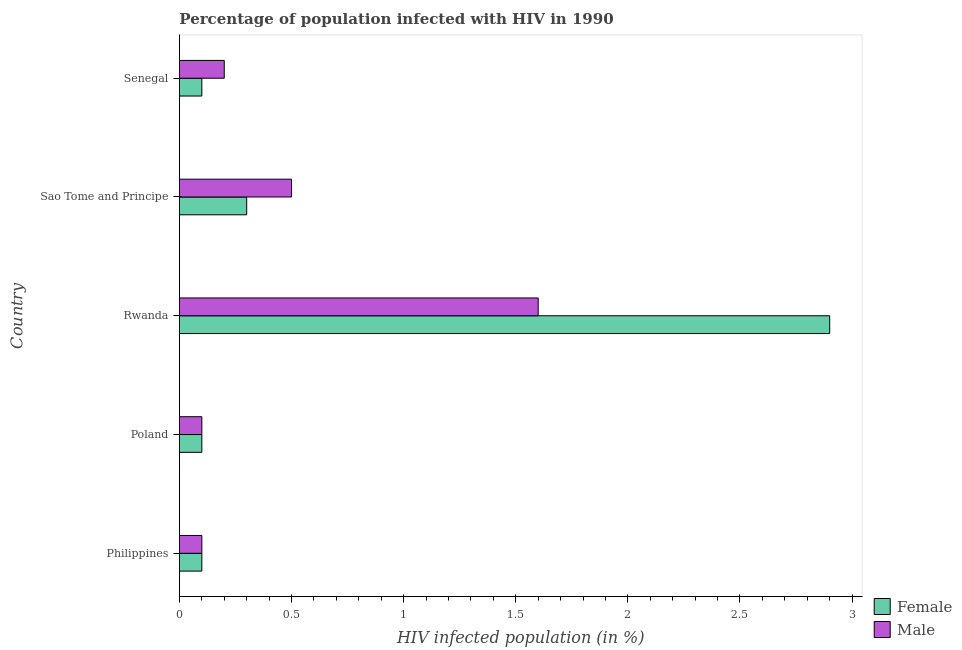How many different coloured bars are there?
Ensure brevity in your answer.  2. Are the number of bars per tick equal to the number of legend labels?
Offer a very short reply. Yes. Are the number of bars on each tick of the Y-axis equal?
Make the answer very short. Yes. How many bars are there on the 5th tick from the top?
Keep it short and to the point. 2. What is the label of the 2nd group of bars from the top?
Keep it short and to the point. Sao Tome and Principe. In how many cases, is the number of bars for a given country not equal to the number of legend labels?
Give a very brief answer. 0. What is the percentage of females who are infected with hiv in Philippines?
Your answer should be very brief. 0.1. Across all countries, what is the maximum percentage of females who are infected with hiv?
Provide a short and direct response. 2.9. Across all countries, what is the minimum percentage of females who are infected with hiv?
Your response must be concise. 0.1. In which country was the percentage of males who are infected with hiv maximum?
Provide a succinct answer. Rwanda. In which country was the percentage of females who are infected with hiv minimum?
Offer a very short reply. Philippines. What is the difference between the percentage of females who are infected with hiv in Sao Tome and Principe and that in Senegal?
Make the answer very short. 0.2. What is the difference between the percentage of males who are infected with hiv in Senegal and the percentage of females who are infected with hiv in Rwanda?
Your response must be concise. -2.7. What is the average percentage of males who are infected with hiv per country?
Provide a short and direct response. 0.5. What is the difference between the percentage of females who are infected with hiv and percentage of males who are infected with hiv in Rwanda?
Ensure brevity in your answer.  1.3. In how many countries, is the percentage of females who are infected with hiv greater than 1.9 %?
Your response must be concise. 1. Is the difference between the percentage of females who are infected with hiv in Poland and Rwanda greater than the difference between the percentage of males who are infected with hiv in Poland and Rwanda?
Offer a terse response. No. What is the difference between the highest and the lowest percentage of females who are infected with hiv?
Your answer should be very brief. 2.8. In how many countries, is the percentage of females who are infected with hiv greater than the average percentage of females who are infected with hiv taken over all countries?
Give a very brief answer. 1. Is the sum of the percentage of females who are infected with hiv in Rwanda and Sao Tome and Principe greater than the maximum percentage of males who are infected with hiv across all countries?
Give a very brief answer. Yes. What does the 2nd bar from the top in Poland represents?
Your answer should be very brief. Female. What does the 2nd bar from the bottom in Rwanda represents?
Make the answer very short. Male. How many bars are there?
Your answer should be compact. 10. Are all the bars in the graph horizontal?
Your answer should be compact. Yes. How many countries are there in the graph?
Make the answer very short. 5. What is the difference between two consecutive major ticks on the X-axis?
Offer a terse response. 0.5. Does the graph contain any zero values?
Make the answer very short. No. How many legend labels are there?
Give a very brief answer. 2. What is the title of the graph?
Ensure brevity in your answer.  Percentage of population infected with HIV in 1990. What is the label or title of the X-axis?
Give a very brief answer. HIV infected population (in %). What is the label or title of the Y-axis?
Your answer should be very brief. Country. What is the HIV infected population (in %) in Male in Philippines?
Provide a short and direct response. 0.1. What is the HIV infected population (in %) of Male in Poland?
Your answer should be compact. 0.1. What is the HIV infected population (in %) of Male in Rwanda?
Provide a short and direct response. 1.6. What is the HIV infected population (in %) in Male in Sao Tome and Principe?
Your response must be concise. 0.5. Across all countries, what is the maximum HIV infected population (in %) in Female?
Offer a terse response. 2.9. Across all countries, what is the maximum HIV infected population (in %) in Male?
Give a very brief answer. 1.6. Across all countries, what is the minimum HIV infected population (in %) of Male?
Your response must be concise. 0.1. What is the total HIV infected population (in %) of Male in the graph?
Your answer should be very brief. 2.5. What is the difference between the HIV infected population (in %) of Female in Philippines and that in Poland?
Make the answer very short. 0. What is the difference between the HIV infected population (in %) of Male in Philippines and that in Poland?
Provide a succinct answer. 0. What is the difference between the HIV infected population (in %) of Female in Philippines and that in Rwanda?
Offer a terse response. -2.8. What is the difference between the HIV infected population (in %) of Female in Poland and that in Rwanda?
Make the answer very short. -2.8. What is the difference between the HIV infected population (in %) of Male in Poland and that in Rwanda?
Keep it short and to the point. -1.5. What is the difference between the HIV infected population (in %) in Female in Poland and that in Sao Tome and Principe?
Ensure brevity in your answer.  -0.2. What is the difference between the HIV infected population (in %) in Male in Poland and that in Sao Tome and Principe?
Your answer should be compact. -0.4. What is the difference between the HIV infected population (in %) in Male in Rwanda and that in Senegal?
Ensure brevity in your answer.  1.4. What is the difference between the HIV infected population (in %) of Female in Sao Tome and Principe and that in Senegal?
Ensure brevity in your answer.  0.2. What is the difference between the HIV infected population (in %) in Male in Sao Tome and Principe and that in Senegal?
Your answer should be very brief. 0.3. What is the difference between the HIV infected population (in %) of Female in Philippines and the HIV infected population (in %) of Male in Sao Tome and Principe?
Make the answer very short. -0.4. What is the difference between the HIV infected population (in %) of Female in Poland and the HIV infected population (in %) of Male in Rwanda?
Make the answer very short. -1.5. What is the difference between the HIV infected population (in %) in Female in Poland and the HIV infected population (in %) in Male in Senegal?
Provide a short and direct response. -0.1. What is the difference between the HIV infected population (in %) of Female in Rwanda and the HIV infected population (in %) of Male in Senegal?
Offer a terse response. 2.7. What is the difference between the HIV infected population (in %) of Female and HIV infected population (in %) of Male in Rwanda?
Provide a succinct answer. 1.3. What is the difference between the HIV infected population (in %) in Female and HIV infected population (in %) in Male in Sao Tome and Principe?
Your answer should be compact. -0.2. What is the ratio of the HIV infected population (in %) of Female in Philippines to that in Poland?
Your answer should be very brief. 1. What is the ratio of the HIV infected population (in %) in Female in Philippines to that in Rwanda?
Offer a terse response. 0.03. What is the ratio of the HIV infected population (in %) in Male in Philippines to that in Rwanda?
Keep it short and to the point. 0.06. What is the ratio of the HIV infected population (in %) in Female in Philippines to that in Sao Tome and Principe?
Offer a terse response. 0.33. What is the ratio of the HIV infected population (in %) of Male in Philippines to that in Sao Tome and Principe?
Offer a very short reply. 0.2. What is the ratio of the HIV infected population (in %) in Female in Poland to that in Rwanda?
Your response must be concise. 0.03. What is the ratio of the HIV infected population (in %) of Male in Poland to that in Rwanda?
Provide a short and direct response. 0.06. What is the ratio of the HIV infected population (in %) of Male in Poland to that in Senegal?
Offer a terse response. 0.5. What is the ratio of the HIV infected population (in %) in Female in Rwanda to that in Sao Tome and Principe?
Your answer should be very brief. 9.67. What is the ratio of the HIV infected population (in %) in Male in Rwanda to that in Sao Tome and Principe?
Ensure brevity in your answer.  3.2. What is the ratio of the HIV infected population (in %) in Female in Rwanda to that in Senegal?
Your answer should be very brief. 29. What is the ratio of the HIV infected population (in %) of Male in Rwanda to that in Senegal?
Your answer should be compact. 8. What is the difference between the highest and the lowest HIV infected population (in %) in Male?
Your answer should be very brief. 1.5. 